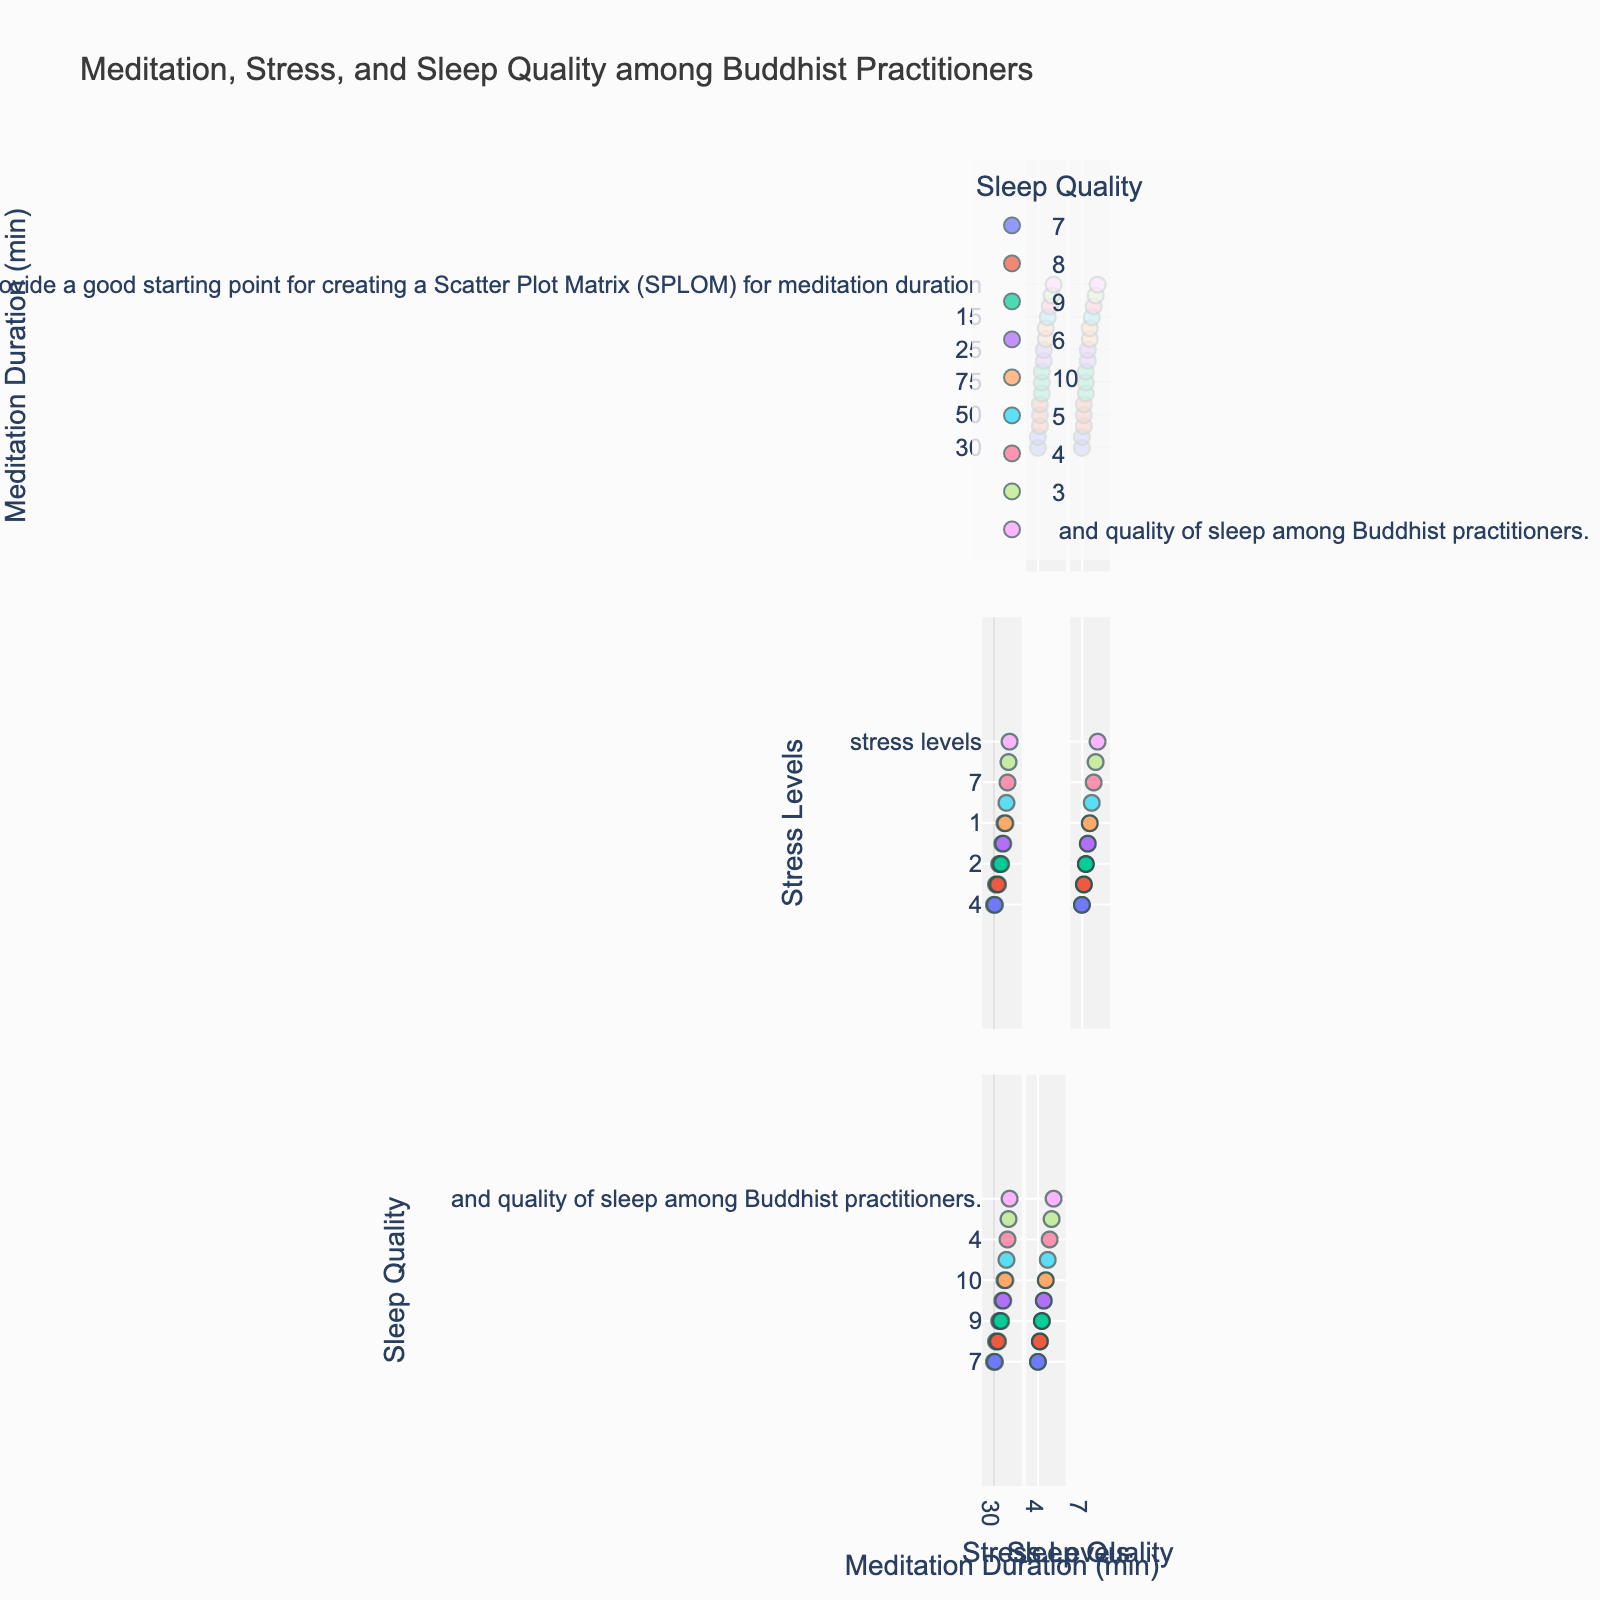What is the title of the figure? The title is usually placed at the top of the figure and is intended to give viewers a summary of what the plot is about. Just read the text at the top.
Answer: Meditation, Stress, and Sleep Quality among Buddhist Practitioners On which axis is 'Stress Levels' plotted? In a scatter plot matrix, each variable is plotted along both axes in different subplots. You can look at the labels on the horizontal and vertical axes to find 'Stress Levels'.
Answer: Both What is the color scale used in the plot? The color scale is typically indicated in the color bar, which is usually positioned next to the plot. Looking at it will tell you what the color scale represents.
Answer: Sunset How many data points are represented in the figure? Count the number of points in any of the scatter plots. Since the dataset is consistent across all subplots, you can sum up the individual points.
Answer: 15 Which variable is color-coded in the matrix? In a scatter plot matrix, the color-coding variable usually has a corresponding title in the color bar. You can look at the bar to see the title.
Answer: Quality of Sleep What does the highest stress level correspond to in terms of meditation duration? Locate the point with the highest stress level on the 'Stress Levels' axis in any of the subplots and then check the corresponding 'Meditation Duration' value.
Answer: 5 minutes Is there a pattern or relationship between meditation duration and quality of sleep? To find a pattern or relationship, look for trends such as clusters or alignments in the subplots involving 'Meditation Duration' and 'Quality of Sleep'.
Answer: Positive relationship (longer duration, better sleep quality) How does 'Quality of Sleep' change as 'Stress Levels' decreases? By observing the plots where 'Stress Levels' and 'Quality of Sleep' are axes, you can see if there's a trend, such as points rising or falling as they move along the axes.
Answer: Quality of Sleep increases Between which two values does the majority of 'Meditation Duration' fall? Look at the distribution of points along the 'Meditation Duration' axis across applicable subplots to determine the range where most points are situated.
Answer: 20 to 60 minutes When stress level is 2, what range of 'Quality of Sleep' can be expected? Locate the points where 'Stress Levels' are 2 in relevant subplots, and then note down the range of 'Quality of Sleep' values for those points.
Answer: 9 to 10 